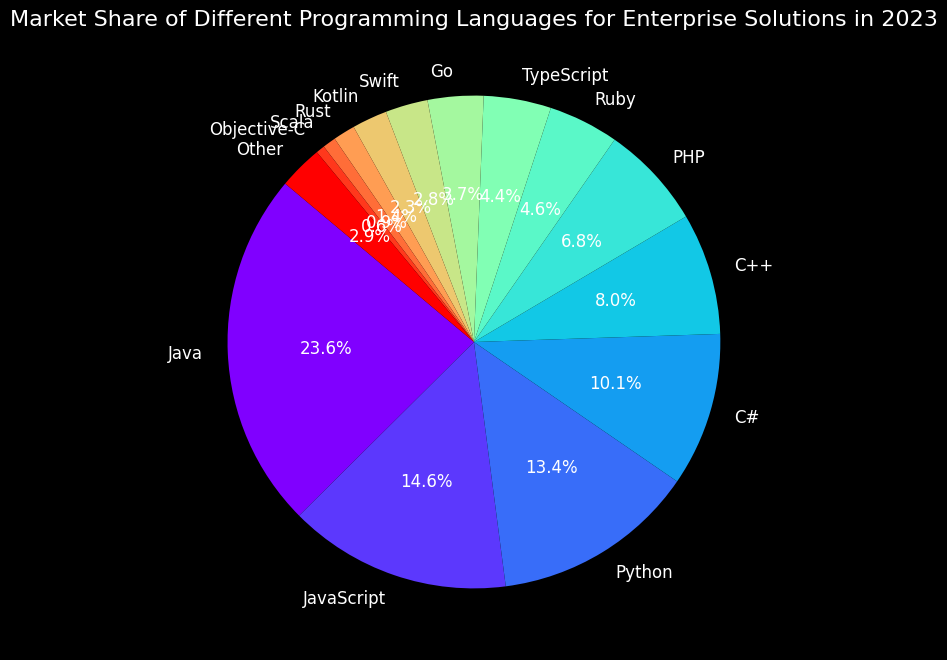Which language has the largest market share? The pie chart shows that Java has the largest market share, denoted by the largest section and a label indicating 24.5%.
Answer: Java What is the combined market share of C++ and PHP? To find the combined market share, sum the percentages of C++ (8.3%) and PHP (7.1%). This gives 8.3 + 7.1 = 15.4%.
Answer: 15.4% Is Python's market share greater than JavaScript's? The pie chart shows the market share of Python as 13.9% and JavaScript as 15.2%. Since 13.9 < 15.2, Python's market share is not greater than JavaScript's.
Answer: No Between Swift and Kotlin, which language has a smaller market share and by how much? The pie chart shows Swift with 2.9% and Kotlin with 2.4%. To find the difference, subtract Kotlin's share from Swift's share: 2.9 - 2.4 = 0.5%.
Answer: Kotlin, by 0.5% What is the market share of languages having less than 5% share individually and what is their total? The languages with less than 5% market share are Ruby (4.8%), TypeScript (4.6%), Go (3.8%), Swift (2.9%), Kotlin (2.4%), Rust (1.5%), Scala (0.9%), and Objective-C (0.6%). Sum these percentages: 4.8 + 4.6 + 3.8 + 2.9 + 2.4 + 1.5 + 0.9 + 0.6 = 21.5%.
Answer: 8 languages, 21.5% How does the market share of Java compare to the combined market share of Python and C#? The market share of Java is 24.5%. The combined market share of Python (13.9%) and C# (10.5%) is 13.9 + 10.5 = 24.4%. Comparing the two values, 24.5% (Java) is slightly greater than 24.4% (Python and C# combined).
Answer: Java is slightly greater What percentage of the market is controlled by languages other than the top 5 mentioned languages? The market shares of the top 5 languages (Java, JavaScript, Python, C#, C++) sum to 24.5 + 15.2 + 13.9 + 10.5 + 8.3 = 72.4%. Therefore, the market share of other languages is 100% - 72.4% = 27.6%.
Answer: 27.6% Which language has the least market share and what is its percentage? The pie chart's smallest section is labeled with Objective-C, showing a market share of 0.6%.
Answer: Objective-C, 0.6% What is the average market share of the top 3 languages? The top 3 languages are Java (24.5%), JavaScript (15.2%), and Python (13.9%). Their combined market share is 24.5 + 15.2 + 13.9 = 53.6%. The average is 53.6 / 3 = 17.87%.
Answer: 17.87% Which languages, based on their colors on the pie chart, are visually adjacent to Java on either side? Based on the colors, the sections adjacent to Java's section are JavaScript (typically to one side) and "Other" languages or the one in its color section immediately following or preceding it visually. Identification relies on the visual adjacency in the color spectrum around Java's segment.
Answer: JavaScript and "Other (closest section)" 